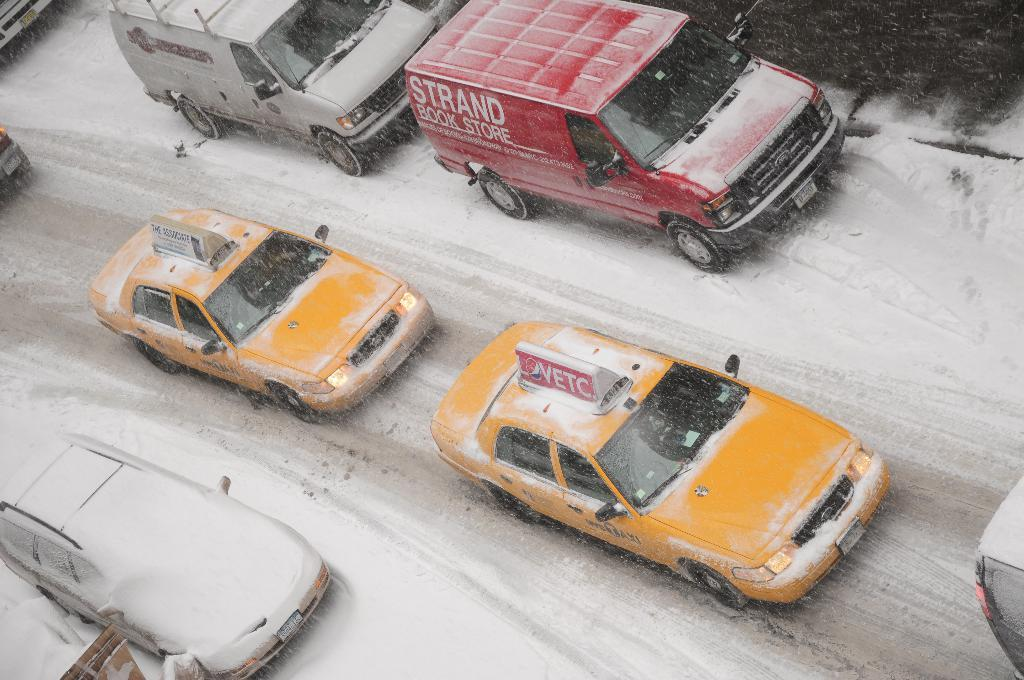Provide a one-sentence caption for the provided image. Several vehicles are riding down a snowy street with a taxi cab having a sign for vetc on top of it. 